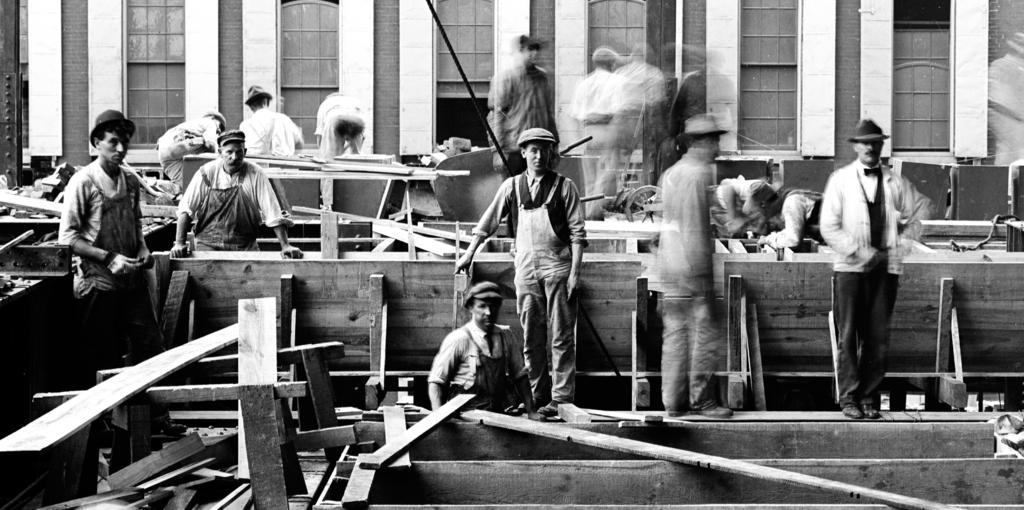Please provide a concise description of this image. In the picture we can see black and white photograph of some men are standing near the wooden planks and in the background we can see a wall with windows to it. 